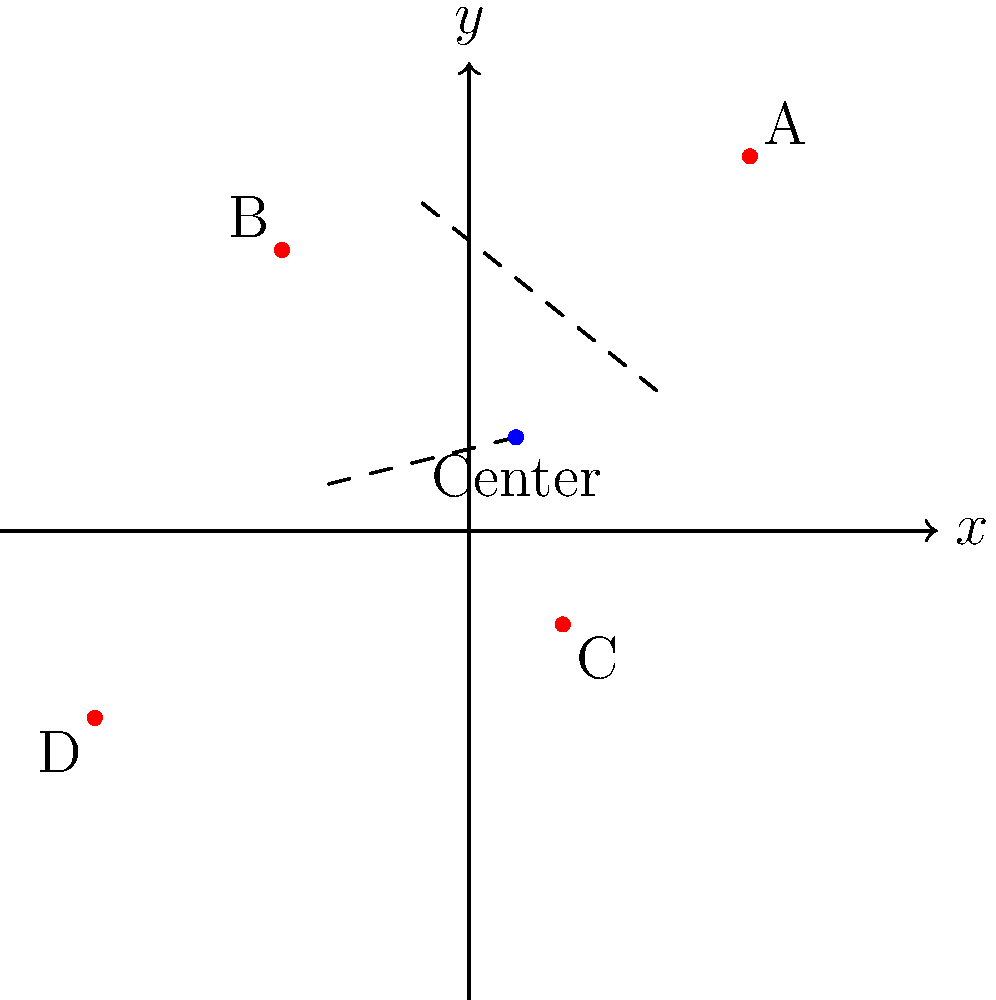You're planning to install a central monitoring station for your wind turbine farm. The farm consists of four turbines located at the following coordinates: A(6,8), B(-4,6), C(2,-2), and D(-8,-4). To minimize wiring costs, you want to place the monitoring station at the center of the farm. Using the midpoint formula, calculate the coordinates of the center point where the monitoring station should be installed. To find the center point of the wind farm, we'll use the midpoint formula twice:

1. First, find the midpoint of diagonal AC:
   $M_{AC} = (\frac{x_A + x_C}{2}, \frac{y_A + y_C}{2}) = (\frac{6 + 2}{2}, \frac{8 + (-2)}{2}) = (4, 3)$

2. Then, find the midpoint of diagonal BD:
   $M_{BD} = (\frac{x_B + x_D}{2}, \frac{y_B + y_D}{2}) = (\frac{-4 + (-8)}{2}, \frac{6 + (-4)}{2}) = (-6, 1)$

3. The center point of the farm will be the midpoint of these two midpoints:
   $Center = (\frac{x_{M_{AC}} + x_{M_{BD}}}{2}, \frac{y_{M_{AC}} + y_{M_{BD}}}{2})$
   $= (\frac{4 + (-6)}{2}, \frac{3 + 1}{2})$
   $= (-1, 2)$

Therefore, the coordinates of the center point where the monitoring station should be installed are (-1, 2).
Answer: (-1, 2) 